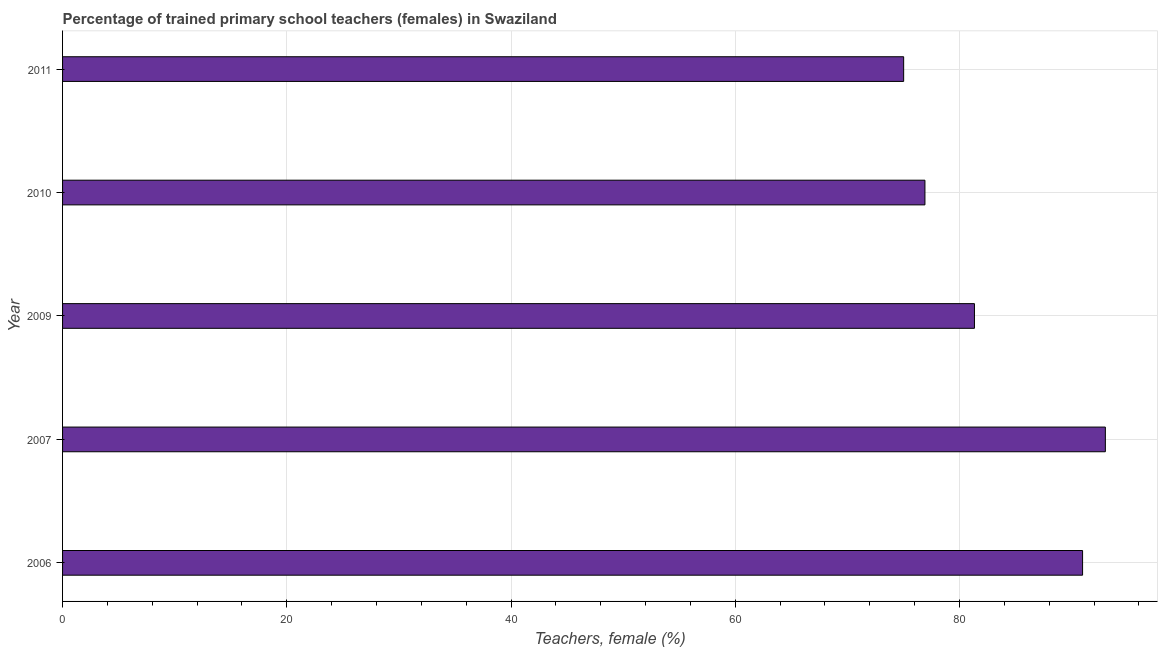Does the graph contain any zero values?
Provide a succinct answer. No. Does the graph contain grids?
Your answer should be very brief. Yes. What is the title of the graph?
Make the answer very short. Percentage of trained primary school teachers (females) in Swaziland. What is the label or title of the X-axis?
Ensure brevity in your answer.  Teachers, female (%). What is the percentage of trained female teachers in 2011?
Your answer should be compact. 75.02. Across all years, what is the maximum percentage of trained female teachers?
Offer a terse response. 93.01. Across all years, what is the minimum percentage of trained female teachers?
Offer a very short reply. 75.02. In which year was the percentage of trained female teachers maximum?
Keep it short and to the point. 2007. What is the sum of the percentage of trained female teachers?
Keep it short and to the point. 417.27. What is the difference between the percentage of trained female teachers in 2007 and 2009?
Give a very brief answer. 11.68. What is the average percentage of trained female teachers per year?
Ensure brevity in your answer.  83.45. What is the median percentage of trained female teachers?
Offer a terse response. 81.34. In how many years, is the percentage of trained female teachers greater than 36 %?
Provide a succinct answer. 5. Do a majority of the years between 2011 and 2010 (inclusive) have percentage of trained female teachers greater than 80 %?
Offer a terse response. No. What is the ratio of the percentage of trained female teachers in 2009 to that in 2011?
Give a very brief answer. 1.08. Is the percentage of trained female teachers in 2006 less than that in 2007?
Make the answer very short. Yes. Is the difference between the percentage of trained female teachers in 2007 and 2009 greater than the difference between any two years?
Give a very brief answer. No. What is the difference between the highest and the second highest percentage of trained female teachers?
Make the answer very short. 2.03. What is the difference between the highest and the lowest percentage of trained female teachers?
Make the answer very short. 17.99. In how many years, is the percentage of trained female teachers greater than the average percentage of trained female teachers taken over all years?
Keep it short and to the point. 2. What is the Teachers, female (%) of 2006?
Ensure brevity in your answer.  90.98. What is the Teachers, female (%) of 2007?
Your answer should be very brief. 93.01. What is the Teachers, female (%) in 2009?
Ensure brevity in your answer.  81.34. What is the Teachers, female (%) of 2010?
Offer a terse response. 76.92. What is the Teachers, female (%) in 2011?
Make the answer very short. 75.02. What is the difference between the Teachers, female (%) in 2006 and 2007?
Your answer should be very brief. -2.03. What is the difference between the Teachers, female (%) in 2006 and 2009?
Make the answer very short. 9.64. What is the difference between the Teachers, female (%) in 2006 and 2010?
Your answer should be very brief. 14.06. What is the difference between the Teachers, female (%) in 2006 and 2011?
Your answer should be very brief. 15.96. What is the difference between the Teachers, female (%) in 2007 and 2009?
Ensure brevity in your answer.  11.68. What is the difference between the Teachers, female (%) in 2007 and 2010?
Keep it short and to the point. 16.09. What is the difference between the Teachers, female (%) in 2007 and 2011?
Give a very brief answer. 17.99. What is the difference between the Teachers, female (%) in 2009 and 2010?
Make the answer very short. 4.42. What is the difference between the Teachers, female (%) in 2009 and 2011?
Give a very brief answer. 6.31. What is the difference between the Teachers, female (%) in 2010 and 2011?
Your answer should be very brief. 1.9. What is the ratio of the Teachers, female (%) in 2006 to that in 2007?
Provide a succinct answer. 0.98. What is the ratio of the Teachers, female (%) in 2006 to that in 2009?
Your answer should be compact. 1.12. What is the ratio of the Teachers, female (%) in 2006 to that in 2010?
Offer a very short reply. 1.18. What is the ratio of the Teachers, female (%) in 2006 to that in 2011?
Give a very brief answer. 1.21. What is the ratio of the Teachers, female (%) in 2007 to that in 2009?
Offer a very short reply. 1.14. What is the ratio of the Teachers, female (%) in 2007 to that in 2010?
Provide a succinct answer. 1.21. What is the ratio of the Teachers, female (%) in 2007 to that in 2011?
Provide a succinct answer. 1.24. What is the ratio of the Teachers, female (%) in 2009 to that in 2010?
Your answer should be very brief. 1.06. What is the ratio of the Teachers, female (%) in 2009 to that in 2011?
Provide a short and direct response. 1.08. 